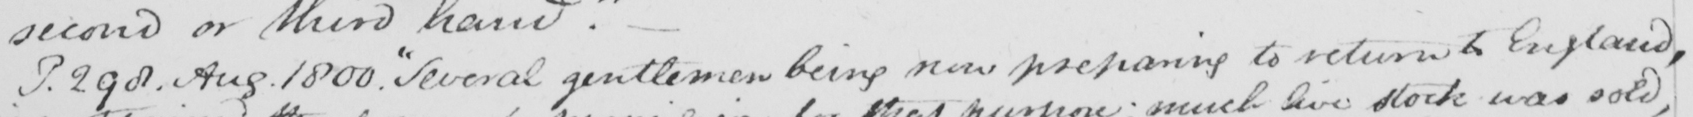Can you tell me what this handwritten text says? P . 298 . Aug . 1800 .  " Several gentlemen being now preparing to return to England , 